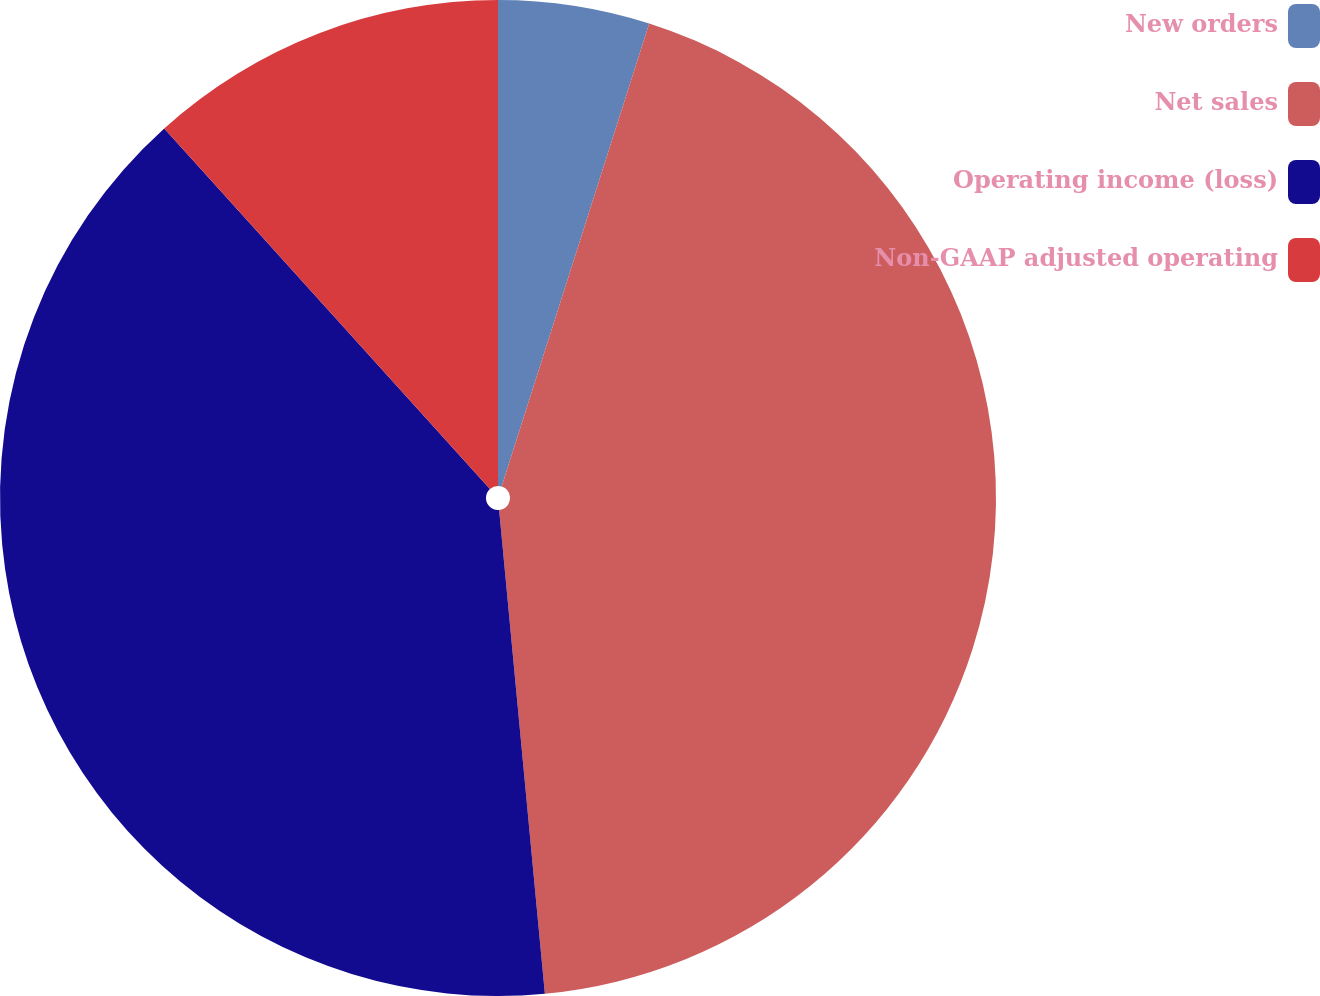Convert chart. <chart><loc_0><loc_0><loc_500><loc_500><pie_chart><fcel>New orders<fcel>Net sales<fcel>Operating income (loss)<fcel>Non-GAAP adjusted operating<nl><fcel>4.91%<fcel>43.59%<fcel>39.81%<fcel>11.69%<nl></chart> 